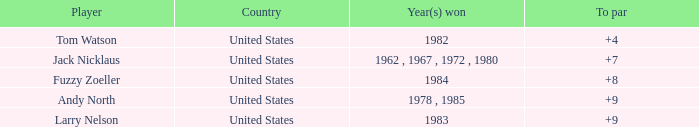What is andy north's country with a to par exceeding 8? United States. 